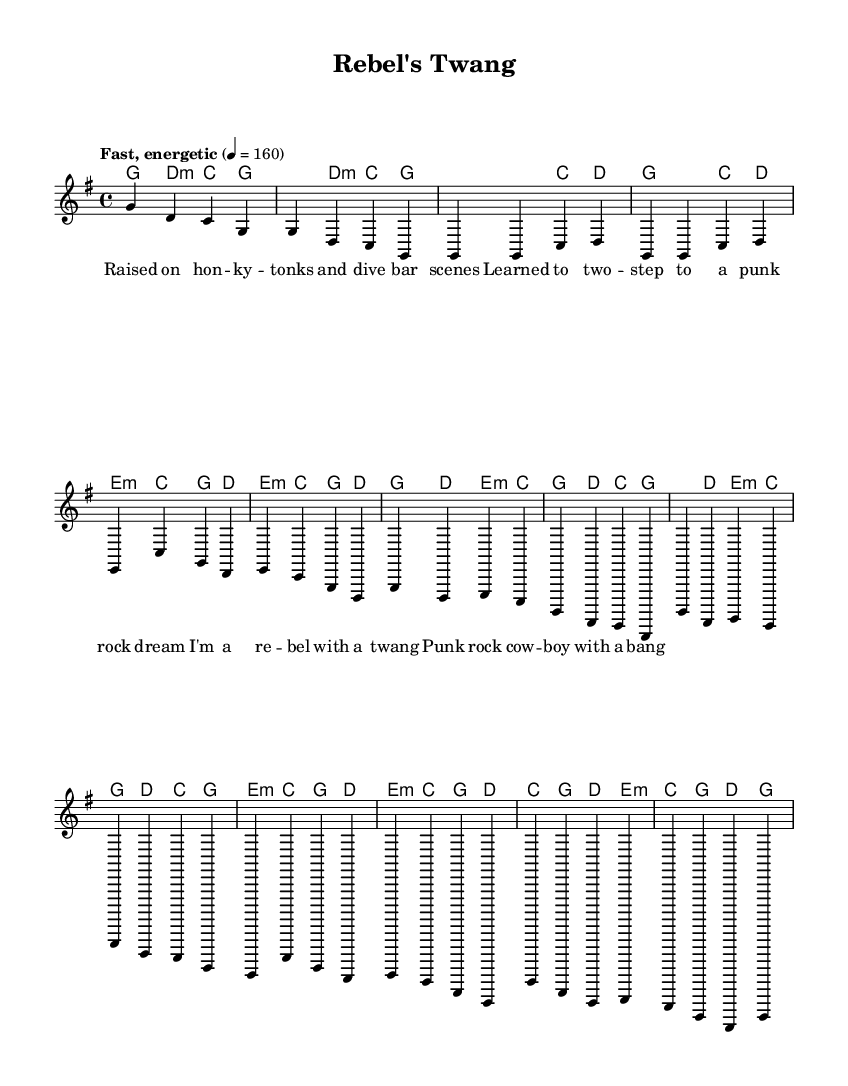What is the key signature of this music? The key signature is G major, which has one sharp (F#). This is determined by looking at the key signature indicated at the beginning of the score.
Answer: G major What is the time signature? The time signature is 4/4, indicated at the beginning of the score. This means there are four beats in each measure, and the quarter note receives one beat.
Answer: 4/4 What is the tempo marking? The tempo marking is "Fast, energetic," indicated at the beginning of the score along with a metronome marking of 160 beats per minute. This informs the performer about the intended speed of the piece.
Answer: Fast, energetic How many measures are there in the verse? The verse consists of 8 measures, as counted from the melody section specifically labeled as Verse 1. Each set of notes corresponds to one measure.
Answer: 8 What chord progression is used in the chorus? The chord progression in the chorus is G, D, E minor, C, which is consistent through the repeated sections. This can be analyzed by reading the chord symbols written above the melody in the score.
Answer: G, D, E minor, C How does the punk influence manifest in the lyrics? The punk influence manifests through themes of rebellion and counterculture, highlighted in the lyrics such as "I'm a rebel with a twang," which reflects the ethos of both punk rock and outlaw country. This combines an attitude of defiance with the traditional elements of country music.
Answer: Lyrics What instrumental role does the lead melody represent in the context of punk? The lead melody represents the driving energy and raw expression typical in punk music, which often features strong melodies played at a fast tempo, capturing the spirit of punk's rebellious nature. This reflects how punk rock's characteristics shift into a country context while still retaining that energetic intensity.
Answer: Lead melody 